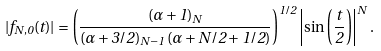<formula> <loc_0><loc_0><loc_500><loc_500>| f _ { N , 0 } ( t ) | = \left ( \frac { ( \alpha + 1 ) _ { N } } { ( \alpha + 3 / 2 ) _ { N - 1 } \, ( \alpha + N / 2 + 1 / 2 ) } \right ) ^ { 1 / 2 } \left | \sin \left ( \frac { t } { 2 } \right ) \right | ^ { N } .</formula> 